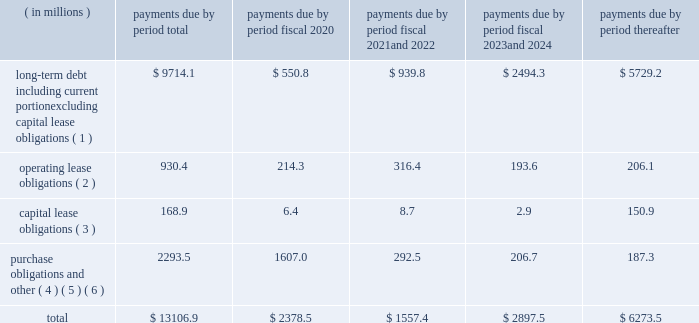Factors , including the market price of our common stock , general economic and market conditions and applicable legal requirements .
The repurchase program may be commenced , suspended or discontinued at any time .
In fiscal 2019 , we repurchased approximately 2.1 million shares of our common stock for an aggregate cost of $ 88.6 million .
In fiscal 2018 , we repurchased approximately 3.4 million shares of our common stock for an aggregate cost of $ 195.1 million .
As of september 30 , 2019 , we had approximately 19.1 million shares of common stock available for repurchase under the program .
We anticipate that we will be able to fund our capital expenditures , interest payments , dividends and stock repurchases , pension payments , working capital needs , note repurchases , restructuring activities , repayments of current portion of long-term debt and other corporate actions for the foreseeable future from cash generated from operations , borrowings under our credit facilities , proceeds from our a/r sales agreement , proceeds from the issuance of debt or equity securities or other additional long-term debt financing , including new or amended facilities .
In addition , we continually review our capital structure and conditions in the private and public debt markets in order to optimize our mix of indebtedness .
In connection with these reviews , we may seek to refinance existing indebtedness to extend maturities , reduce borrowing costs or otherwise improve the terms and composition of our indebtedness .
Contractual obligations we summarize our enforceable and legally binding contractual obligations at september 30 , 2019 , and the effect these obligations are expected to have on our liquidity and cash flow in future periods in the table .
Certain amounts in this table are based on management 2019s estimates and assumptions about these obligations , including their duration , the possibility of renewal , anticipated actions by third parties and other factors , including estimated minimum pension plan contributions and estimated benefit payments related to postretirement obligations , supplemental retirement plans and deferred compensation plans .
Because these estimates and assumptions are subjective , the enforceable and legally binding obligations we actually pay in future periods may vary from those presented in the table. .
( 1 ) includes only principal payments owed on our debt assuming that all of our long-term debt will be held to maturity , excluding scheduled payments .
We have excluded $ 163.5 million of fair value of debt step-up , deferred financing costs and unamortized bond discounts from the table to arrive at actual debt obligations .
See 201cnote 13 .
Debt 201d of the notes to consolidated financial statements for information on the interest rates that apply to our various debt instruments .
( 2 ) see 201cnote 15 .
Operating leases 201d of the notes to consolidated financial statements for additional information .
( 3 ) the fair value step-up of $ 16.9 million is excluded .
See 201cnote 13 .
Debt 2014 capital lease and other indebtedness 201d of the notes to consolidated financial statements for additional information .
( 4 ) purchase obligations include agreements to purchase goods or services that are enforceable and legally binding and that specify all significant terms , including : fixed or minimum quantities to be purchased ; fixed , minimum or variable price provision ; and the approximate timing of the transaction .
Purchase obligations exclude agreements that are cancelable without penalty .
( 5 ) we have included in the table future estimated minimum pension plan contributions and estimated benefit payments related to postretirement obligations , supplemental retirement plans and deferred compensation plans .
Our estimates are based on factors , such as discount rates and expected returns on plan assets .
Future contributions are subject to changes in our underfunded status based on factors such as investment performance , discount rates , returns on plan assets and changes in legislation .
It is possible that our assumptions may change , actual market performance may vary or we may decide to contribute different amounts .
We have excluded $ 237.2 million of multiemployer pension plan withdrawal liabilities recorded as of september 30 , 2019 , including our estimate of the accumulated funding deficiency , due to lack of .
What percent of longterm debt payments are deferred until after 2024? 
Computations: (5729.2 / 9714.1)
Answer: 0.58978. Factors , including the market price of our common stock , general economic and market conditions and applicable legal requirements .
The repurchase program may be commenced , suspended or discontinued at any time .
In fiscal 2019 , we repurchased approximately 2.1 million shares of our common stock for an aggregate cost of $ 88.6 million .
In fiscal 2018 , we repurchased approximately 3.4 million shares of our common stock for an aggregate cost of $ 195.1 million .
As of september 30 , 2019 , we had approximately 19.1 million shares of common stock available for repurchase under the program .
We anticipate that we will be able to fund our capital expenditures , interest payments , dividends and stock repurchases , pension payments , working capital needs , note repurchases , restructuring activities , repayments of current portion of long-term debt and other corporate actions for the foreseeable future from cash generated from operations , borrowings under our credit facilities , proceeds from our a/r sales agreement , proceeds from the issuance of debt or equity securities or other additional long-term debt financing , including new or amended facilities .
In addition , we continually review our capital structure and conditions in the private and public debt markets in order to optimize our mix of indebtedness .
In connection with these reviews , we may seek to refinance existing indebtedness to extend maturities , reduce borrowing costs or otherwise improve the terms and composition of our indebtedness .
Contractual obligations we summarize our enforceable and legally binding contractual obligations at september 30 , 2019 , and the effect these obligations are expected to have on our liquidity and cash flow in future periods in the table .
Certain amounts in this table are based on management 2019s estimates and assumptions about these obligations , including their duration , the possibility of renewal , anticipated actions by third parties and other factors , including estimated minimum pension plan contributions and estimated benefit payments related to postretirement obligations , supplemental retirement plans and deferred compensation plans .
Because these estimates and assumptions are subjective , the enforceable and legally binding obligations we actually pay in future periods may vary from those presented in the table. .
( 1 ) includes only principal payments owed on our debt assuming that all of our long-term debt will be held to maturity , excluding scheduled payments .
We have excluded $ 163.5 million of fair value of debt step-up , deferred financing costs and unamortized bond discounts from the table to arrive at actual debt obligations .
See 201cnote 13 .
Debt 201d of the notes to consolidated financial statements for information on the interest rates that apply to our various debt instruments .
( 2 ) see 201cnote 15 .
Operating leases 201d of the notes to consolidated financial statements for additional information .
( 3 ) the fair value step-up of $ 16.9 million is excluded .
See 201cnote 13 .
Debt 2014 capital lease and other indebtedness 201d of the notes to consolidated financial statements for additional information .
( 4 ) purchase obligations include agreements to purchase goods or services that are enforceable and legally binding and that specify all significant terms , including : fixed or minimum quantities to be purchased ; fixed , minimum or variable price provision ; and the approximate timing of the transaction .
Purchase obligations exclude agreements that are cancelable without penalty .
( 5 ) we have included in the table future estimated minimum pension plan contributions and estimated benefit payments related to postretirement obligations , supplemental retirement plans and deferred compensation plans .
Our estimates are based on factors , such as discount rates and expected returns on plan assets .
Future contributions are subject to changes in our underfunded status based on factors such as investment performance , discount rates , returns on plan assets and changes in legislation .
It is possible that our assumptions may change , actual market performance may vary or we may decide to contribute different amounts .
We have excluded $ 237.2 million of multiemployer pension plan withdrawal liabilities recorded as of september 30 , 2019 , including our estimate of the accumulated funding deficiency , due to lack of .
What percent of total payments are due within the next year ( 2020 ) ? 
Computations: (2378.5 / 13106.9)
Answer: 0.18147. 